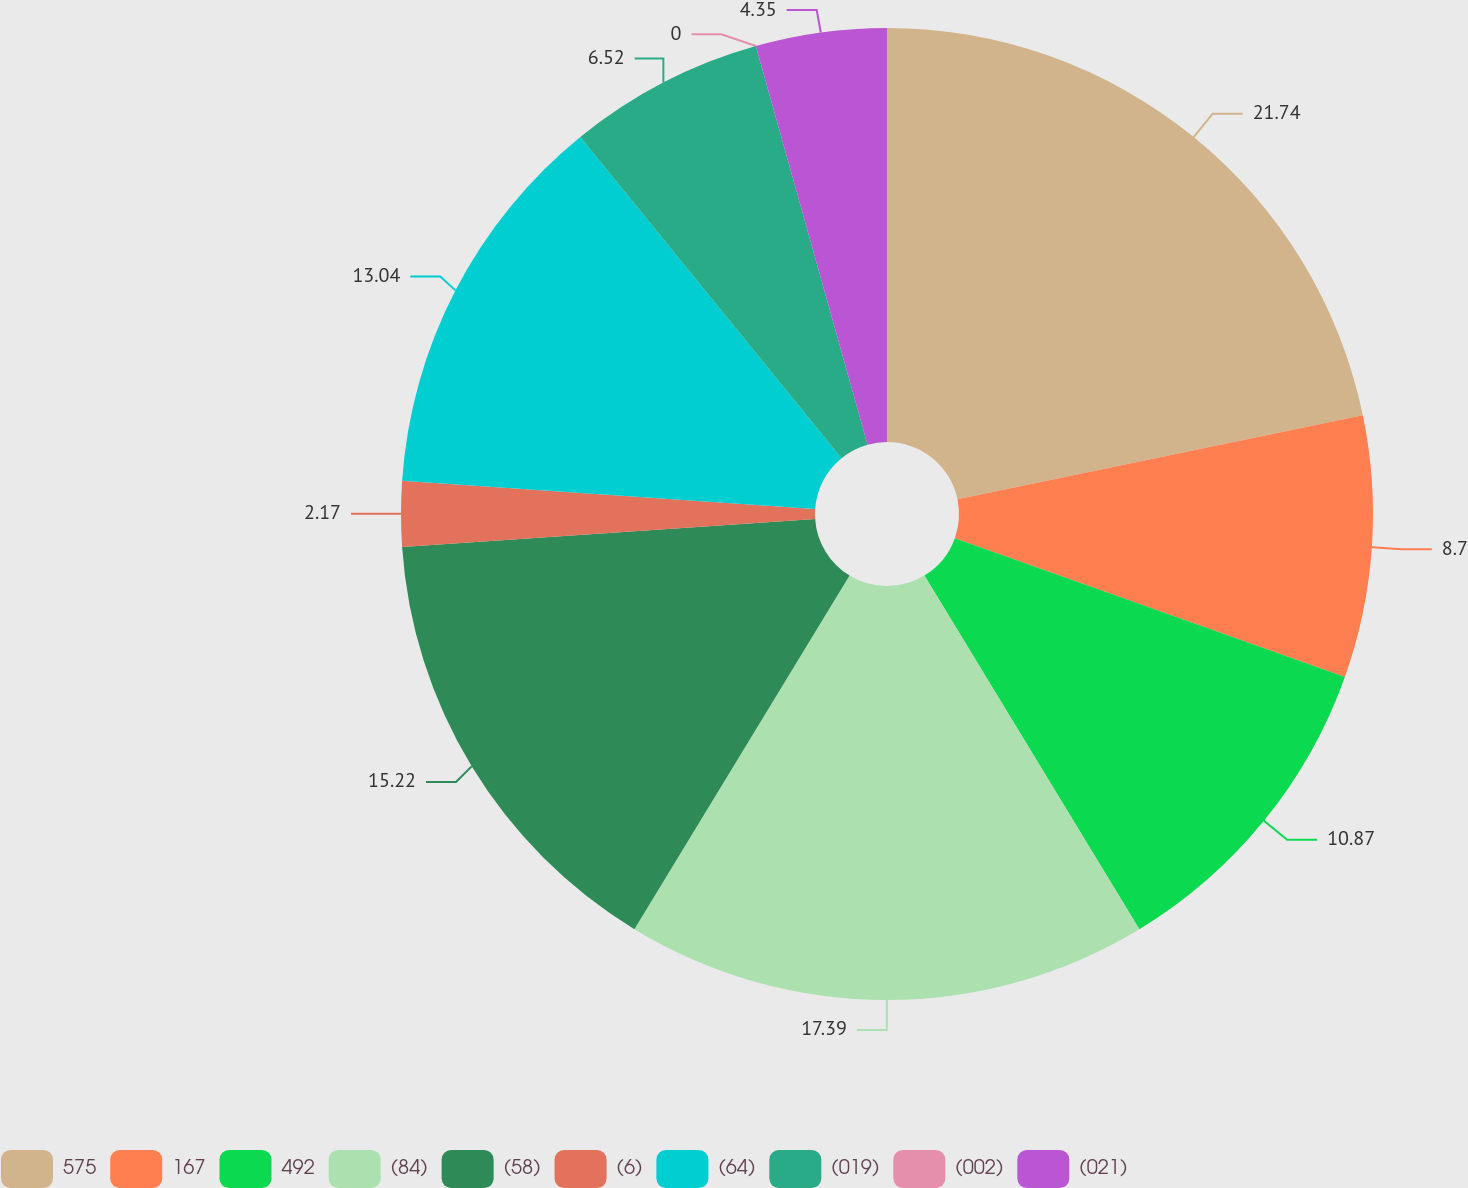Convert chart. <chart><loc_0><loc_0><loc_500><loc_500><pie_chart><fcel>575<fcel>167<fcel>492<fcel>(84)<fcel>(58)<fcel>(6)<fcel>(64)<fcel>(019)<fcel>(002)<fcel>(021)<nl><fcel>21.74%<fcel>8.7%<fcel>10.87%<fcel>17.39%<fcel>15.22%<fcel>2.17%<fcel>13.04%<fcel>6.52%<fcel>0.0%<fcel>4.35%<nl></chart> 